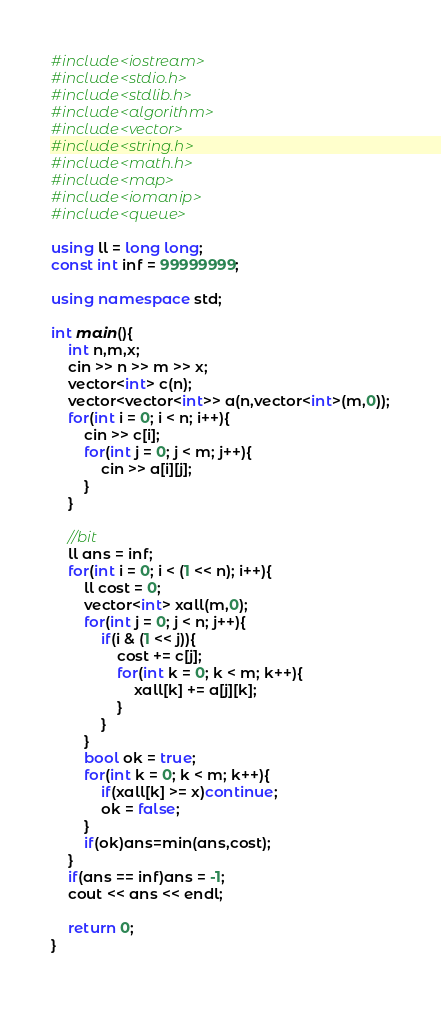<code> <loc_0><loc_0><loc_500><loc_500><_C++_>#include<iostream>
#include<stdio.h>
#include<stdlib.h>
#include<algorithm>
#include<vector>
#include<string.h>
#include<math.h>
#include<map>
#include<iomanip>
#include<queue>

using ll = long long;
const int inf = 99999999;

using namespace std;

int main(){
	int n,m,x;
	cin >> n >> m >> x;
	vector<int> c(n);
	vector<vector<int>> a(n,vector<int>(m,0));
	for(int i = 0; i < n; i++){
		cin >> c[i];
		for(int j = 0; j < m; j++){
			cin >> a[i][j];
		}
	}
	
	//bit 
	ll ans = inf;
	for(int i = 0; i < (1 << n); i++){
		ll cost = 0;
		vector<int> xall(m,0);
		for(int j = 0; j < n; j++){
			if(i & (1 << j)){
				cost += c[j];
				for(int k = 0; k < m; k++){
					xall[k] += a[j][k];
				}
			}
		}
		bool ok = true;
		for(int k = 0; k < m; k++){
			if(xall[k] >= x)continue;
			ok = false;
		}
		if(ok)ans=min(ans,cost);
	}
	if(ans == inf)ans = -1;
	cout << ans << endl;
	
	return 0;
}
 </code> 